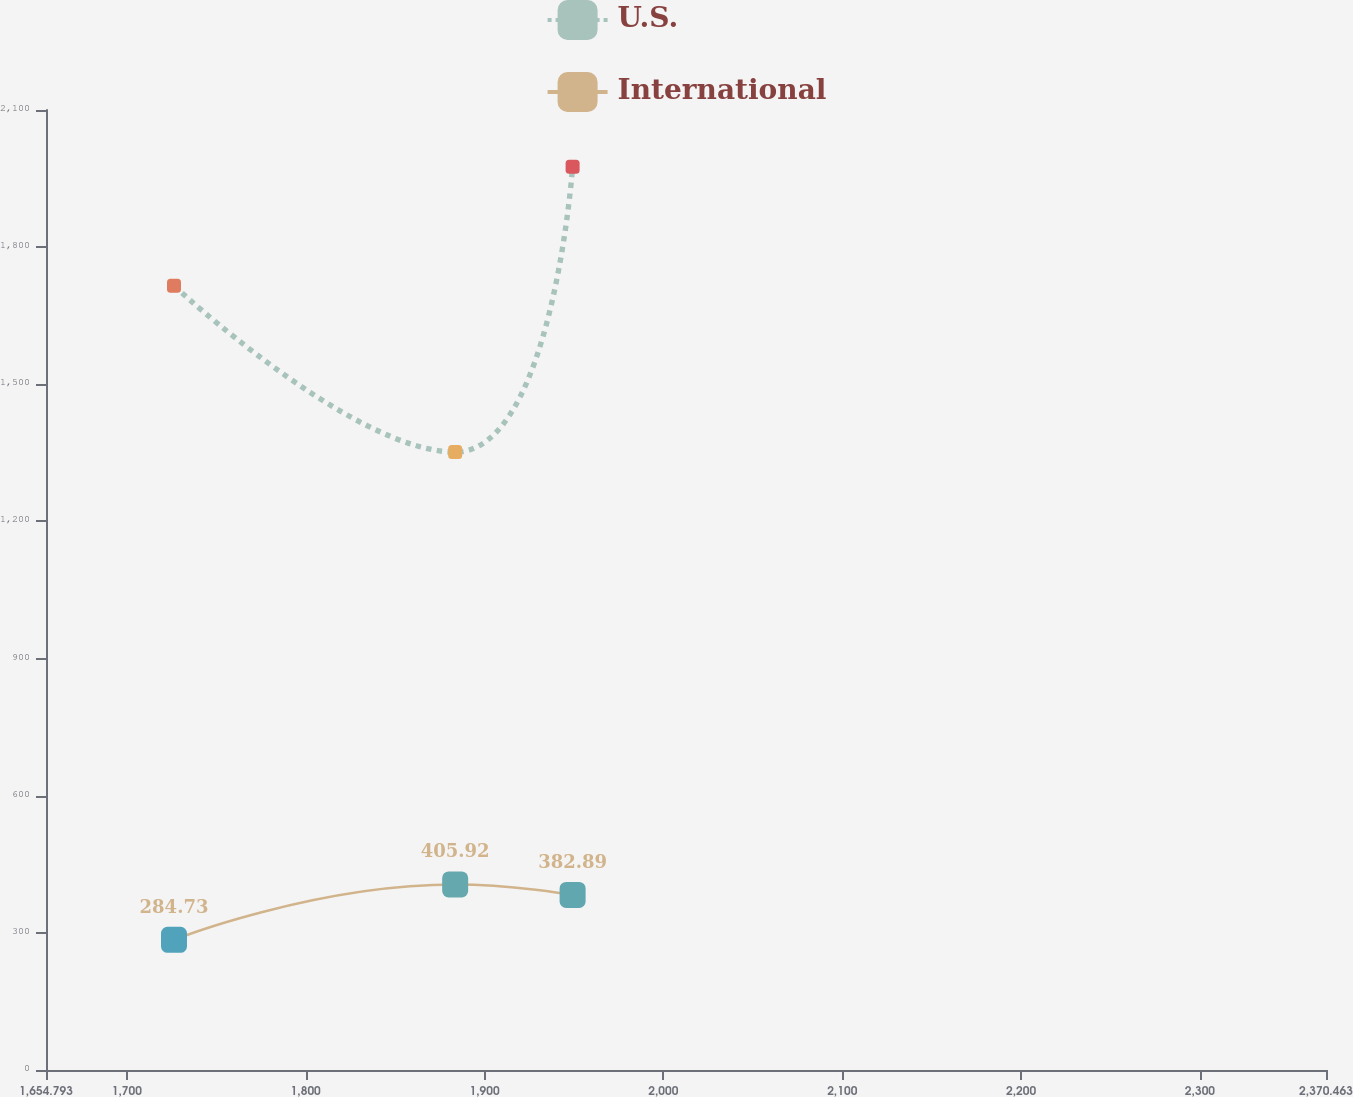Convert chart to OTSL. <chart><loc_0><loc_0><loc_500><loc_500><line_chart><ecel><fcel>U.S.<fcel>International<nl><fcel>1726.36<fcel>1715.52<fcel>284.73<nl><fcel>1883.56<fcel>1351.79<fcel>405.92<nl><fcel>1949.23<fcel>1975.96<fcel>382.89<nl><fcel>2376.36<fcel>2042.57<fcel>301.41<nl><fcel>2442.03<fcel>1621.01<fcel>346.49<nl></chart> 